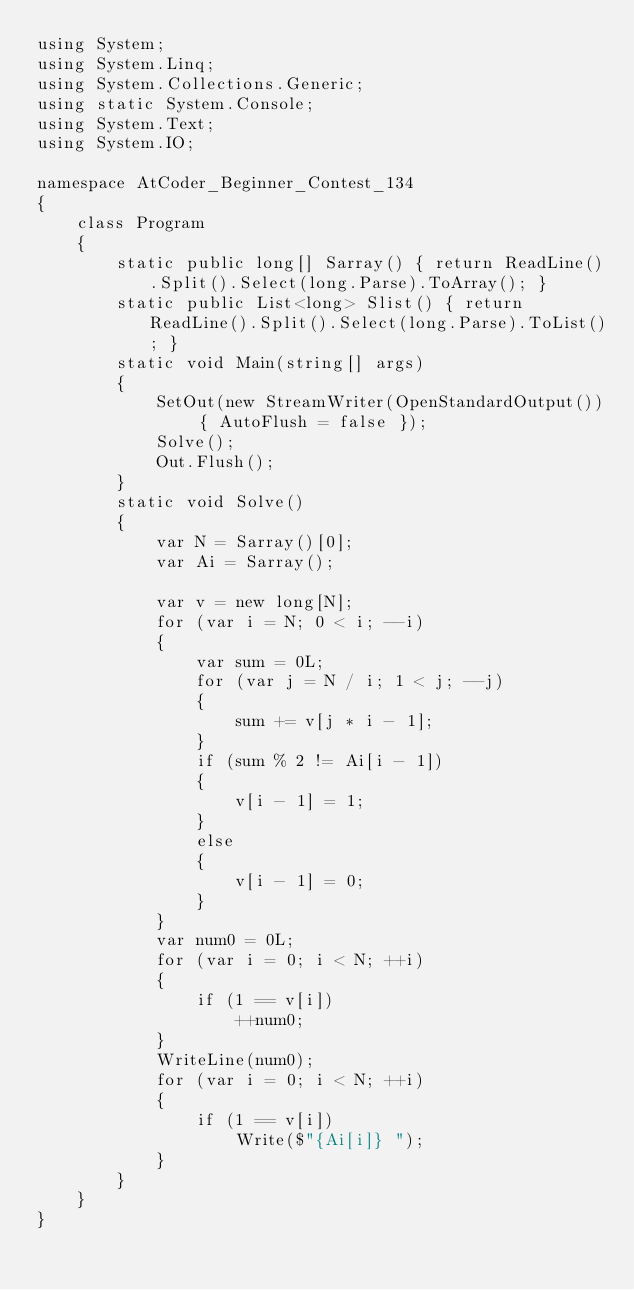Convert code to text. <code><loc_0><loc_0><loc_500><loc_500><_C#_>using System;
using System.Linq;
using System.Collections.Generic;
using static System.Console;
using System.Text;
using System.IO;

namespace AtCoder_Beginner_Contest_134
{
    class Program
    {
        static public long[] Sarray() { return ReadLine().Split().Select(long.Parse).ToArray(); }
        static public List<long> Slist() { return ReadLine().Split().Select(long.Parse).ToList(); }
        static void Main(string[] args)
        {
            SetOut(new StreamWriter(OpenStandardOutput()) { AutoFlush = false });
            Solve();
            Out.Flush();
        }
        static void Solve()
        {
            var N = Sarray()[0];
            var Ai = Sarray();

            var v = new long[N];
            for (var i = N; 0 < i; --i)
            {
                var sum = 0L;
                for (var j = N / i; 1 < j; --j)
                {
                    sum += v[j * i - 1];
                }
                if (sum % 2 != Ai[i - 1])
                {
                    v[i - 1] = 1;
                }
                else
                {
                    v[i - 1] = 0;
                }
            }
            var num0 = 0L;
            for (var i = 0; i < N; ++i)
            {
                if (1 == v[i])
                    ++num0;
            }
            WriteLine(num0);
            for (var i = 0; i < N; ++i)
            {
                if (1 == v[i])
                    Write($"{Ai[i]} ");
            }
        }
    }
}</code> 